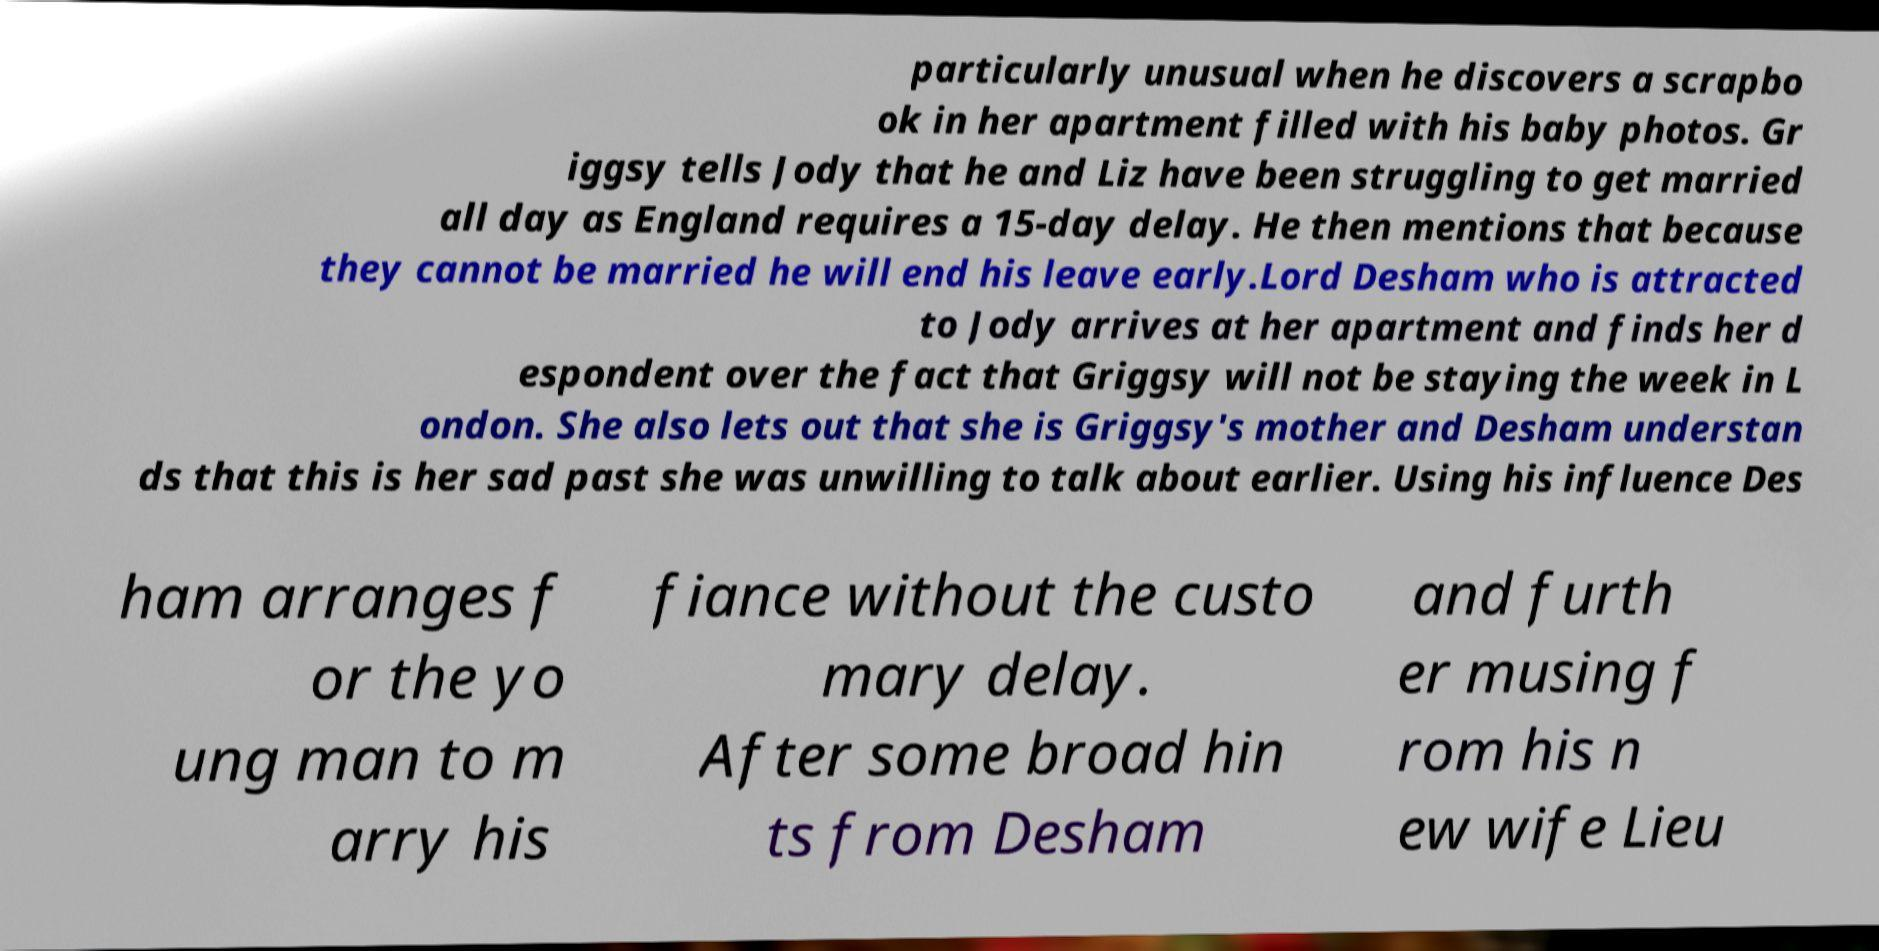Please read and relay the text visible in this image. What does it say? particularly unusual when he discovers a scrapbo ok in her apartment filled with his baby photos. Gr iggsy tells Jody that he and Liz have been struggling to get married all day as England requires a 15-day delay. He then mentions that because they cannot be married he will end his leave early.Lord Desham who is attracted to Jody arrives at her apartment and finds her d espondent over the fact that Griggsy will not be staying the week in L ondon. She also lets out that she is Griggsy's mother and Desham understan ds that this is her sad past she was unwilling to talk about earlier. Using his influence Des ham arranges f or the yo ung man to m arry his fiance without the custo mary delay. After some broad hin ts from Desham and furth er musing f rom his n ew wife Lieu 